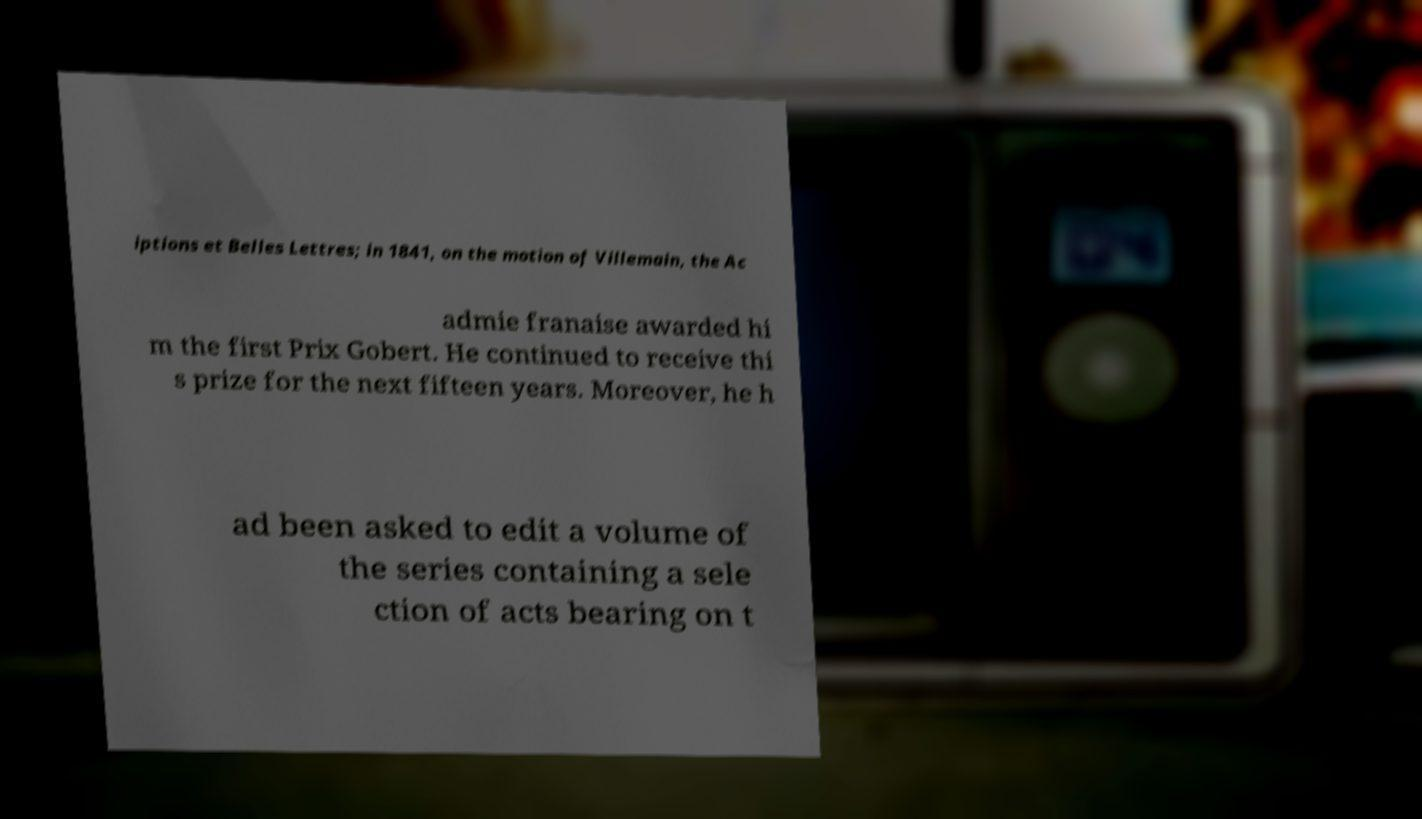What messages or text are displayed in this image? I need them in a readable, typed format. iptions et Belles Lettres; in 1841, on the motion of Villemain, the Ac admie franaise awarded hi m the first Prix Gobert. He continued to receive thi s prize for the next fifteen years. Moreover, he h ad been asked to edit a volume of the series containing a sele ction of acts bearing on t 